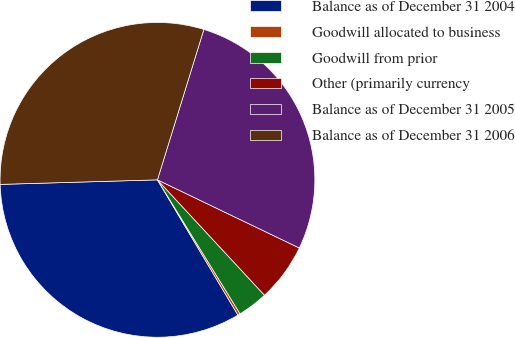Convert chart to OTSL. <chart><loc_0><loc_0><loc_500><loc_500><pie_chart><fcel>Balance as of December 31 2004<fcel>Goodwill allocated to business<fcel>Goodwill from prior<fcel>Other (primarily currency<fcel>Balance as of December 31 2005<fcel>Balance as of December 31 2006<nl><fcel>33.08%<fcel>0.25%<fcel>3.11%<fcel>5.97%<fcel>27.36%<fcel>30.22%<nl></chart> 